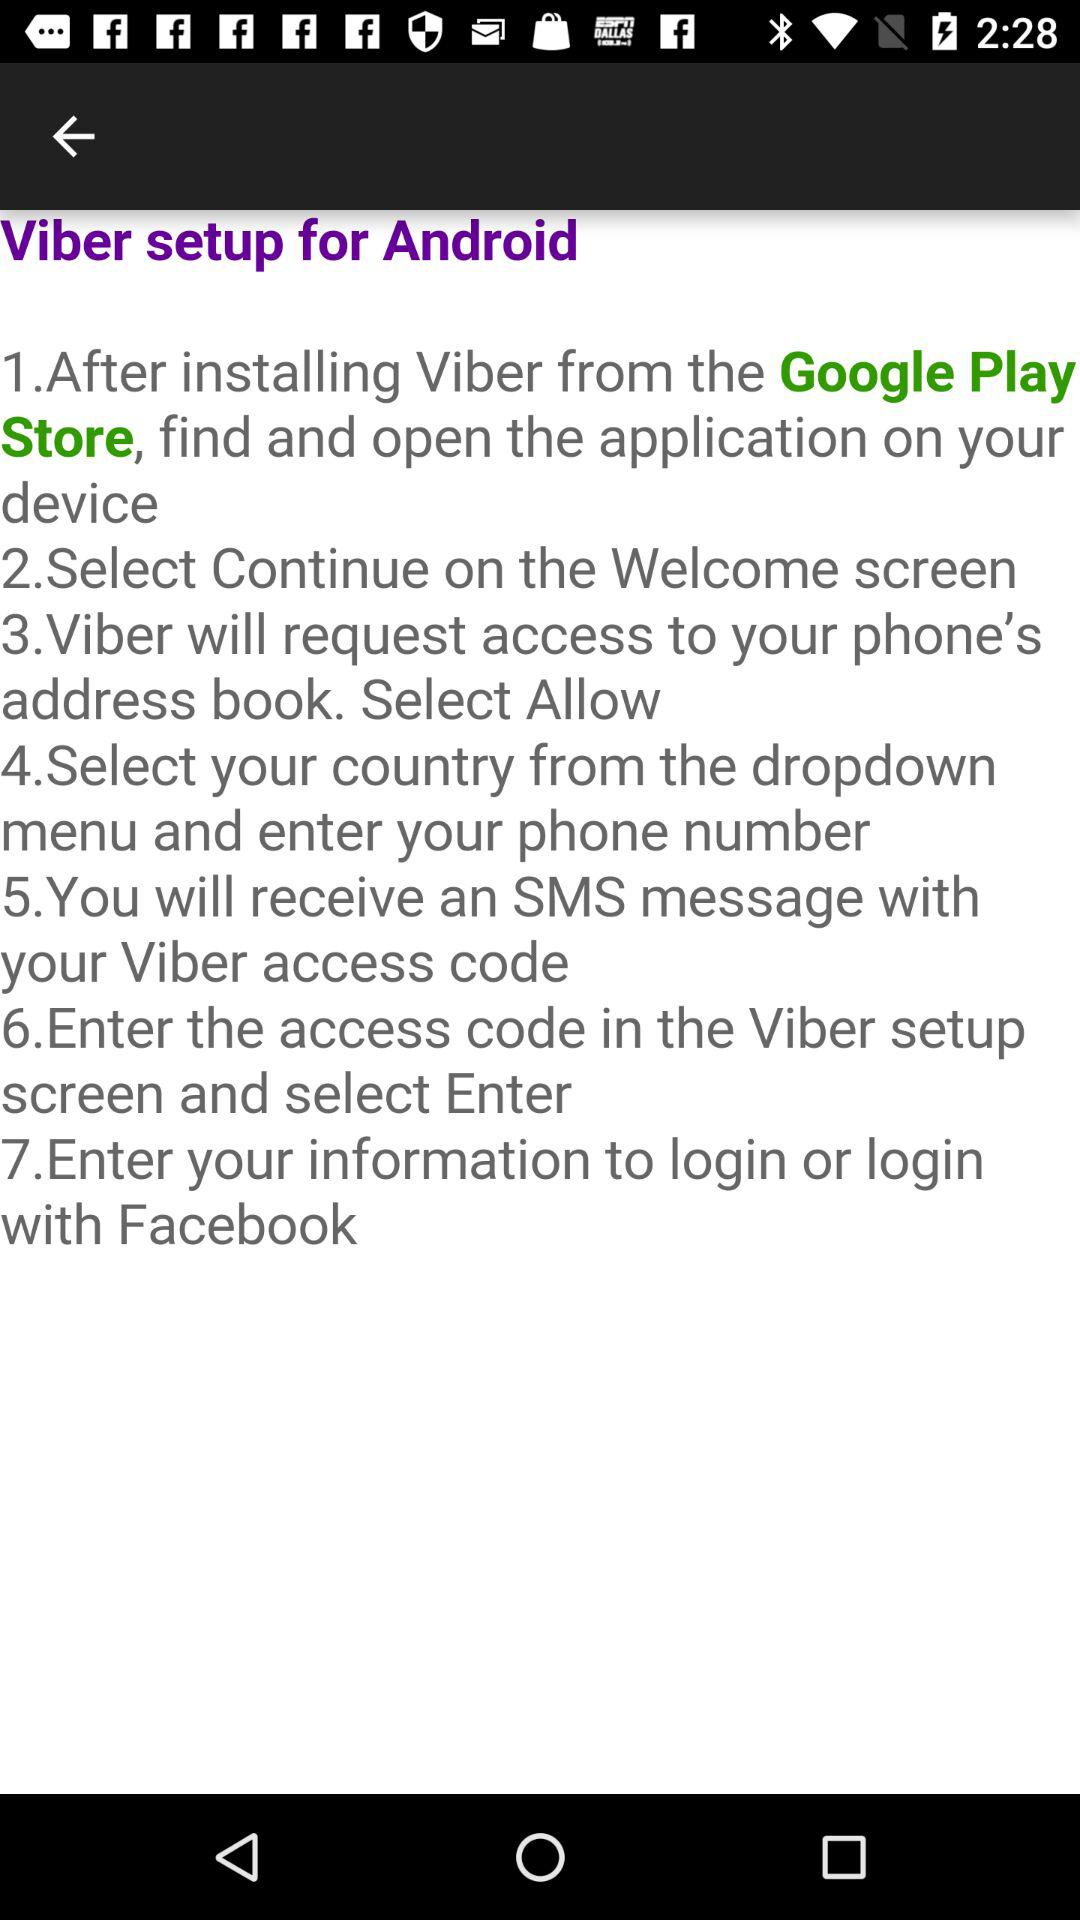How many steps are there in the Viber setup process?
Answer the question using a single word or phrase. 7 